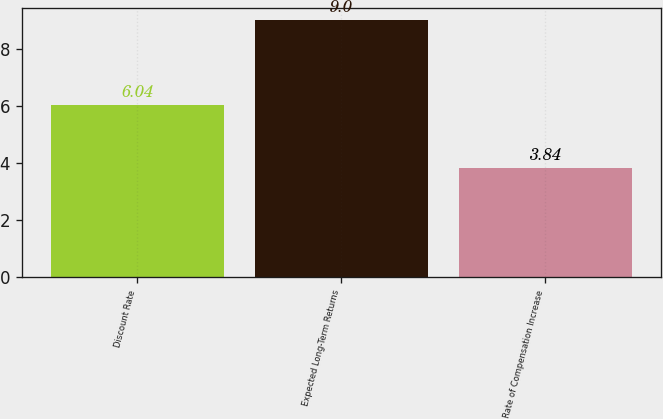Convert chart. <chart><loc_0><loc_0><loc_500><loc_500><bar_chart><fcel>Discount Rate<fcel>Expected Long-Term Returns<fcel>Rate of Compensation Increase<nl><fcel>6.04<fcel>9<fcel>3.84<nl></chart> 